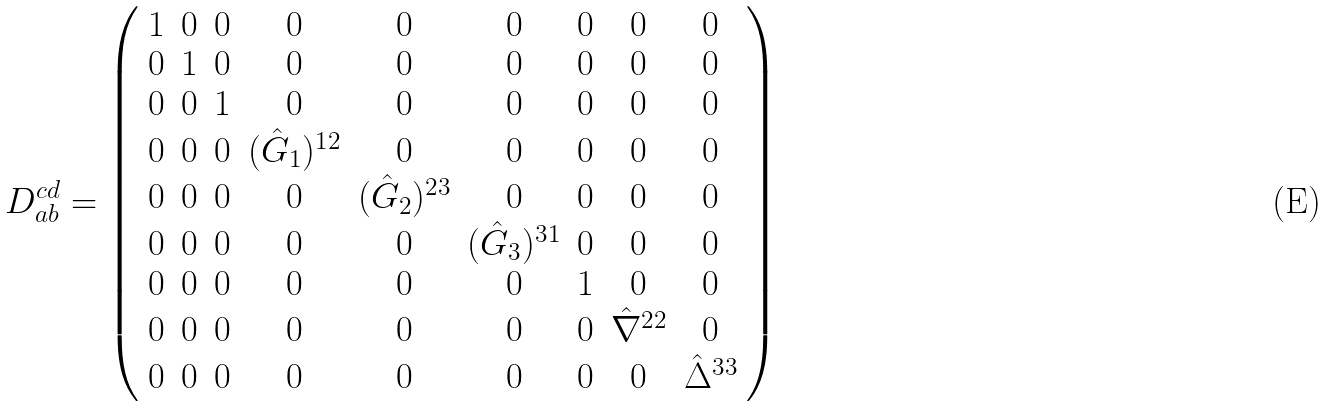Convert formula to latex. <formula><loc_0><loc_0><loc_500><loc_500>D _ { a b } ^ { c d } = \left ( \begin{array} { c c c c c c c c c } 1 & 0 & 0 & 0 & 0 & 0 & 0 & 0 & 0 \\ 0 & 1 & 0 & 0 & 0 & 0 & 0 & 0 & 0 \\ 0 & 0 & 1 & 0 & 0 & 0 & 0 & 0 & 0 \\ 0 & 0 & 0 & ( \hat { G } _ { 1 } ) ^ { 1 2 } & 0 & 0 & 0 & 0 & 0 \\ 0 & 0 & 0 & 0 & ( \hat { G } _ { 2 } ) ^ { 2 3 } & 0 & 0 & 0 & 0 \\ 0 & 0 & 0 & 0 & 0 & ( \hat { G } _ { 3 } ) ^ { 3 1 } & 0 & 0 & 0 \\ 0 & 0 & 0 & 0 & 0 & 0 & 1 & 0 & 0 \\ 0 & 0 & 0 & 0 & 0 & 0 & 0 & \hat { \nabla } ^ { 2 2 } & 0 \\ 0 & 0 & 0 & 0 & 0 & 0 & 0 & 0 & \hat { \Delta } ^ { 3 3 } \\ \end{array} \right )</formula> 